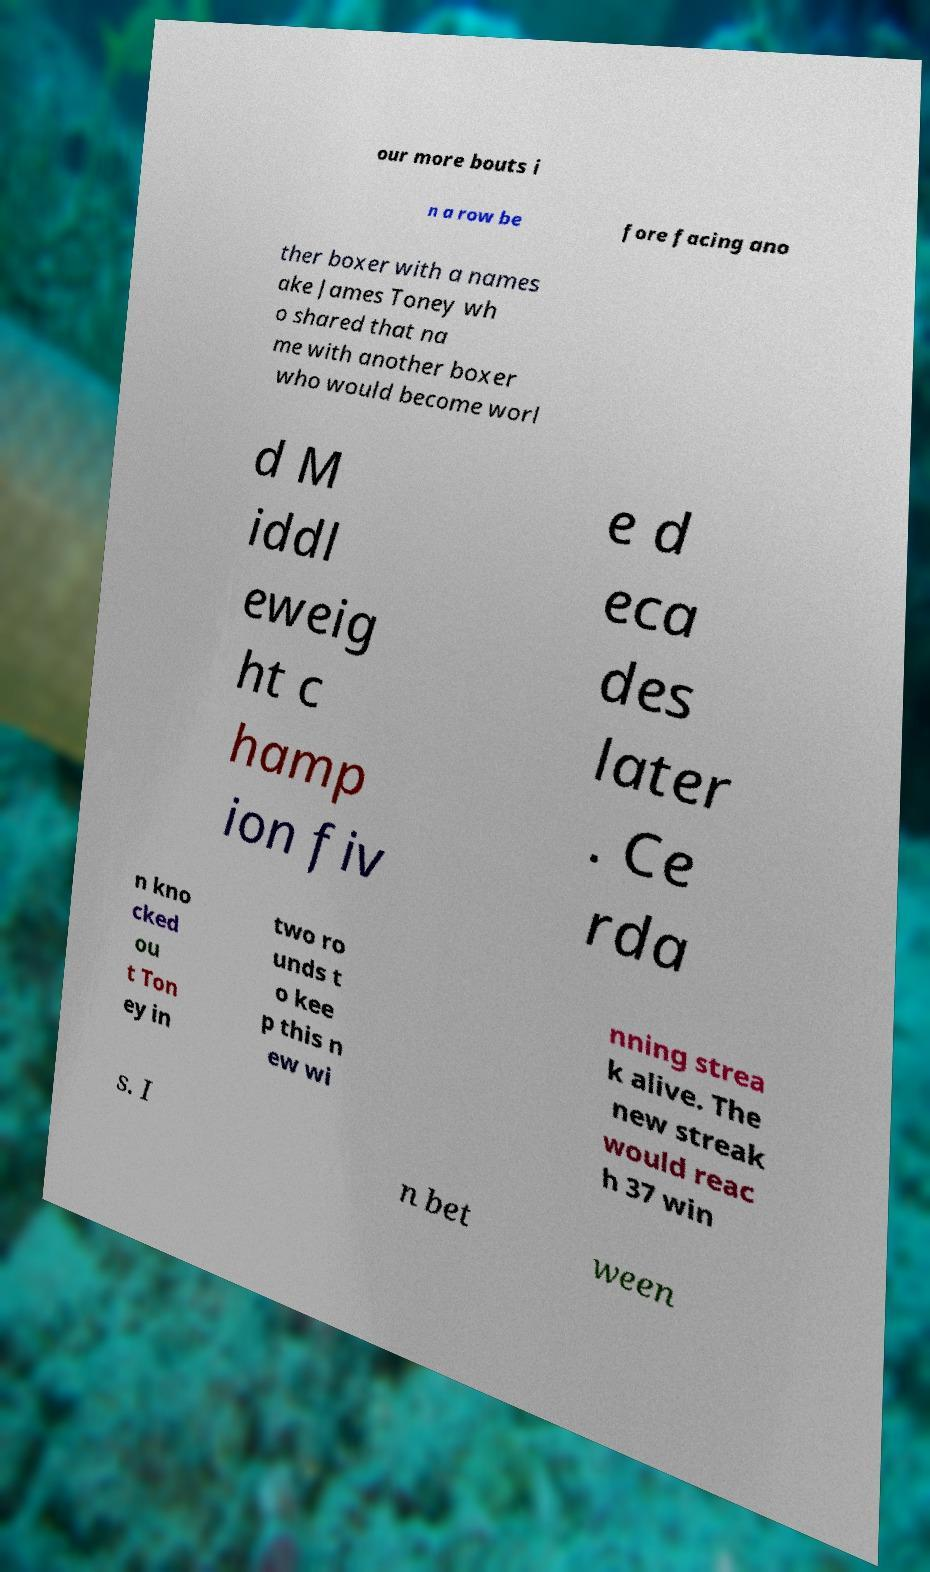Please read and relay the text visible in this image. What does it say? our more bouts i n a row be fore facing ano ther boxer with a names ake James Toney wh o shared that na me with another boxer who would become worl d M iddl eweig ht c hamp ion fiv e d eca des later . Ce rda n kno cked ou t Ton ey in two ro unds t o kee p this n ew wi nning strea k alive. The new streak would reac h 37 win s. I n bet ween 